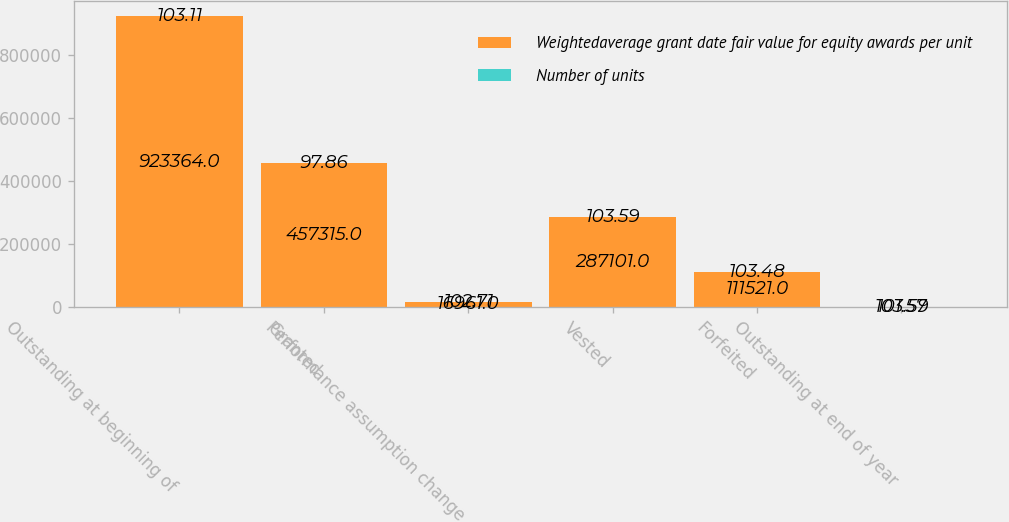Convert chart. <chart><loc_0><loc_0><loc_500><loc_500><stacked_bar_chart><ecel><fcel>Outstanding at beginning of<fcel>Granted<fcel>Performance assumption change<fcel>Vested<fcel>Forfeited<fcel>Outstanding at end of year<nl><fcel>Weightedaverage grant date fair value for equity awards per unit<fcel>923364<fcel>457315<fcel>16961<fcel>287101<fcel>111521<fcel>103.59<nl><fcel>Number of units<fcel>103.11<fcel>97.86<fcel>102.71<fcel>103.59<fcel>103.48<fcel>101.57<nl></chart> 